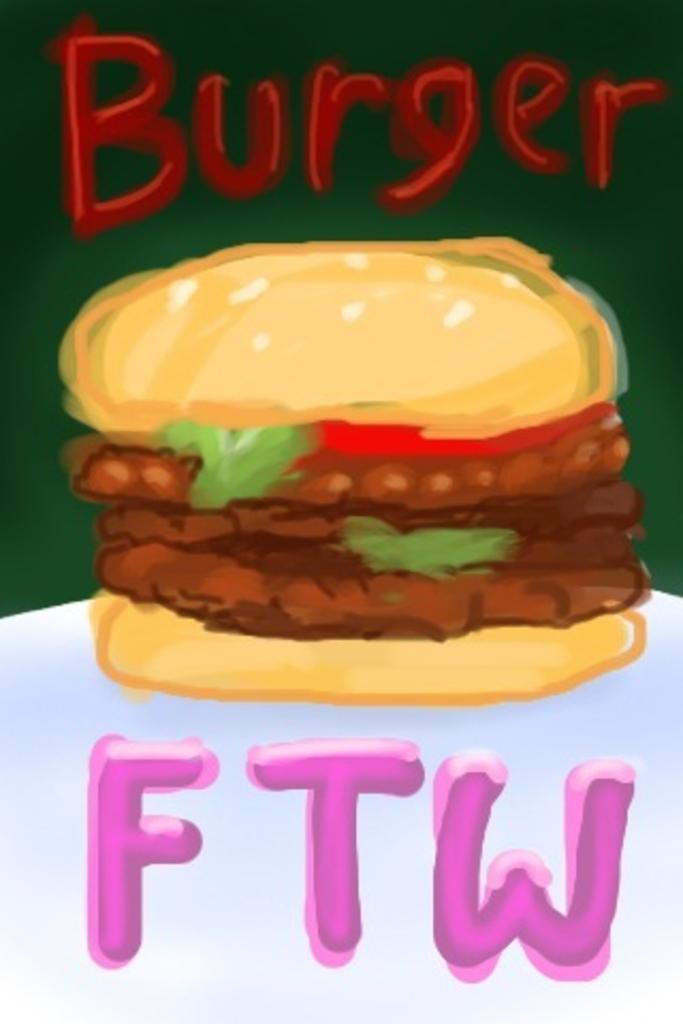Please provide a concise description of this image. In the picture I can see the painting of a burger in the middle of the image. There is a text at the top and at the bottom of the image. 